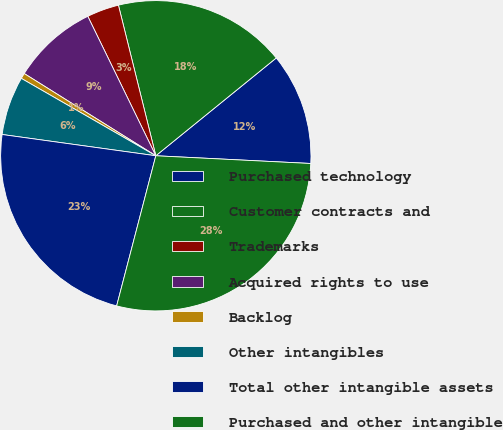Convert chart to OTSL. <chart><loc_0><loc_0><loc_500><loc_500><pie_chart><fcel>Purchased technology<fcel>Customer contracts and<fcel>Trademarks<fcel>Acquired rights to use<fcel>Backlog<fcel>Other intangibles<fcel>Total other intangible assets<fcel>Purchased and other intangible<nl><fcel>11.65%<fcel>18.02%<fcel>3.35%<fcel>8.89%<fcel>0.58%<fcel>6.12%<fcel>23.13%<fcel>28.27%<nl></chart> 